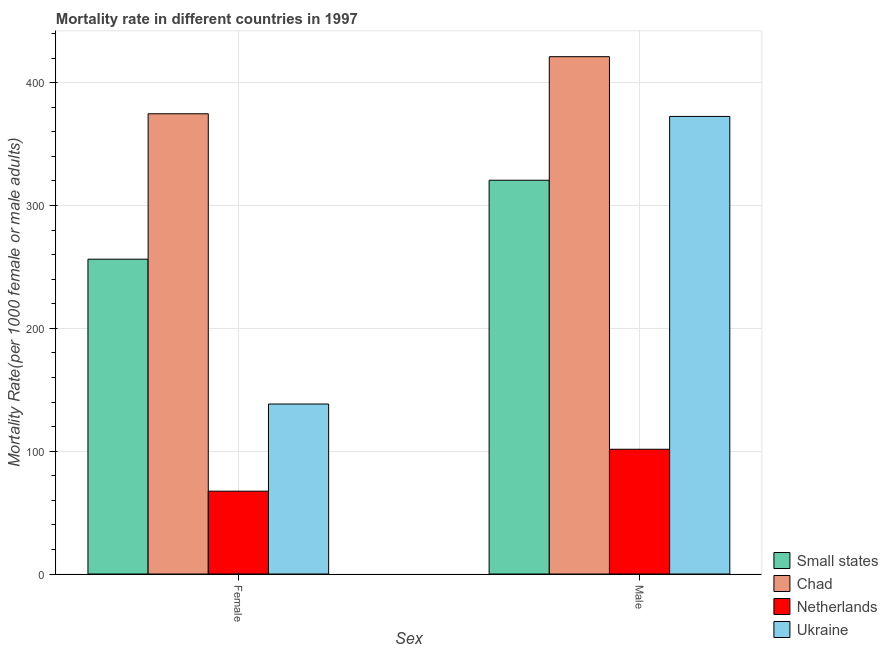Are the number of bars per tick equal to the number of legend labels?
Give a very brief answer. Yes. What is the female mortality rate in Netherlands?
Your answer should be very brief. 67.42. Across all countries, what is the maximum male mortality rate?
Your response must be concise. 421.15. Across all countries, what is the minimum male mortality rate?
Make the answer very short. 101.55. In which country was the female mortality rate maximum?
Your answer should be compact. Chad. What is the total male mortality rate in the graph?
Give a very brief answer. 1215.79. What is the difference between the female mortality rate in Chad and that in Ukraine?
Keep it short and to the point. 236.3. What is the difference between the male mortality rate in Small states and the female mortality rate in Chad?
Your answer should be very brief. -54.11. What is the average female mortality rate per country?
Ensure brevity in your answer.  209.19. What is the difference between the female mortality rate and male mortality rate in Ukraine?
Provide a succinct answer. -234.13. In how many countries, is the male mortality rate greater than 80 ?
Keep it short and to the point. 4. What is the ratio of the male mortality rate in Netherlands to that in Small states?
Provide a short and direct response. 0.32. In how many countries, is the female mortality rate greater than the average female mortality rate taken over all countries?
Provide a succinct answer. 2. What does the 1st bar from the left in Male represents?
Offer a very short reply. Small states. What does the 1st bar from the right in Female represents?
Keep it short and to the point. Ukraine. How many bars are there?
Give a very brief answer. 8. How many countries are there in the graph?
Provide a succinct answer. 4. What is the difference between two consecutive major ticks on the Y-axis?
Your response must be concise. 100. Does the graph contain any zero values?
Your answer should be compact. No. How many legend labels are there?
Ensure brevity in your answer.  4. What is the title of the graph?
Provide a succinct answer. Mortality rate in different countries in 1997. What is the label or title of the X-axis?
Your response must be concise. Sex. What is the label or title of the Y-axis?
Make the answer very short. Mortality Rate(per 1000 female or male adults). What is the Mortality Rate(per 1000 female or male adults) in Small states in Female?
Your response must be concise. 256.29. What is the Mortality Rate(per 1000 female or male adults) of Chad in Female?
Offer a terse response. 374.68. What is the Mortality Rate(per 1000 female or male adults) in Netherlands in Female?
Give a very brief answer. 67.42. What is the Mortality Rate(per 1000 female or male adults) of Ukraine in Female?
Your response must be concise. 138.38. What is the Mortality Rate(per 1000 female or male adults) of Small states in Male?
Offer a terse response. 320.57. What is the Mortality Rate(per 1000 female or male adults) of Chad in Male?
Make the answer very short. 421.15. What is the Mortality Rate(per 1000 female or male adults) of Netherlands in Male?
Your answer should be compact. 101.55. What is the Mortality Rate(per 1000 female or male adults) in Ukraine in Male?
Keep it short and to the point. 372.51. Across all Sex, what is the maximum Mortality Rate(per 1000 female or male adults) in Small states?
Your response must be concise. 320.57. Across all Sex, what is the maximum Mortality Rate(per 1000 female or male adults) in Chad?
Your answer should be compact. 421.15. Across all Sex, what is the maximum Mortality Rate(per 1000 female or male adults) in Netherlands?
Keep it short and to the point. 101.55. Across all Sex, what is the maximum Mortality Rate(per 1000 female or male adults) of Ukraine?
Make the answer very short. 372.51. Across all Sex, what is the minimum Mortality Rate(per 1000 female or male adults) in Small states?
Make the answer very short. 256.29. Across all Sex, what is the minimum Mortality Rate(per 1000 female or male adults) of Chad?
Make the answer very short. 374.68. Across all Sex, what is the minimum Mortality Rate(per 1000 female or male adults) in Netherlands?
Ensure brevity in your answer.  67.42. Across all Sex, what is the minimum Mortality Rate(per 1000 female or male adults) of Ukraine?
Provide a short and direct response. 138.38. What is the total Mortality Rate(per 1000 female or male adults) in Small states in the graph?
Provide a succinct answer. 576.86. What is the total Mortality Rate(per 1000 female or male adults) in Chad in the graph?
Offer a terse response. 795.83. What is the total Mortality Rate(per 1000 female or male adults) in Netherlands in the graph?
Offer a terse response. 168.98. What is the total Mortality Rate(per 1000 female or male adults) of Ukraine in the graph?
Give a very brief answer. 510.89. What is the difference between the Mortality Rate(per 1000 female or male adults) in Small states in Female and that in Male?
Keep it short and to the point. -64.28. What is the difference between the Mortality Rate(per 1000 female or male adults) of Chad in Female and that in Male?
Offer a very short reply. -46.47. What is the difference between the Mortality Rate(per 1000 female or male adults) of Netherlands in Female and that in Male?
Ensure brevity in your answer.  -34.13. What is the difference between the Mortality Rate(per 1000 female or male adults) of Ukraine in Female and that in Male?
Offer a very short reply. -234.13. What is the difference between the Mortality Rate(per 1000 female or male adults) in Small states in Female and the Mortality Rate(per 1000 female or male adults) in Chad in Male?
Offer a terse response. -164.86. What is the difference between the Mortality Rate(per 1000 female or male adults) in Small states in Female and the Mortality Rate(per 1000 female or male adults) in Netherlands in Male?
Your response must be concise. 154.73. What is the difference between the Mortality Rate(per 1000 female or male adults) of Small states in Female and the Mortality Rate(per 1000 female or male adults) of Ukraine in Male?
Provide a short and direct response. -116.22. What is the difference between the Mortality Rate(per 1000 female or male adults) in Chad in Female and the Mortality Rate(per 1000 female or male adults) in Netherlands in Male?
Provide a succinct answer. 273.13. What is the difference between the Mortality Rate(per 1000 female or male adults) in Chad in Female and the Mortality Rate(per 1000 female or male adults) in Ukraine in Male?
Ensure brevity in your answer.  2.17. What is the difference between the Mortality Rate(per 1000 female or male adults) in Netherlands in Female and the Mortality Rate(per 1000 female or male adults) in Ukraine in Male?
Your response must be concise. -305.09. What is the average Mortality Rate(per 1000 female or male adults) of Small states per Sex?
Give a very brief answer. 288.43. What is the average Mortality Rate(per 1000 female or male adults) of Chad per Sex?
Provide a short and direct response. 397.92. What is the average Mortality Rate(per 1000 female or male adults) in Netherlands per Sex?
Your response must be concise. 84.49. What is the average Mortality Rate(per 1000 female or male adults) of Ukraine per Sex?
Give a very brief answer. 255.45. What is the difference between the Mortality Rate(per 1000 female or male adults) in Small states and Mortality Rate(per 1000 female or male adults) in Chad in Female?
Provide a succinct answer. -118.39. What is the difference between the Mortality Rate(per 1000 female or male adults) in Small states and Mortality Rate(per 1000 female or male adults) in Netherlands in Female?
Give a very brief answer. 188.87. What is the difference between the Mortality Rate(per 1000 female or male adults) of Small states and Mortality Rate(per 1000 female or male adults) of Ukraine in Female?
Provide a succinct answer. 117.91. What is the difference between the Mortality Rate(per 1000 female or male adults) of Chad and Mortality Rate(per 1000 female or male adults) of Netherlands in Female?
Your response must be concise. 307.26. What is the difference between the Mortality Rate(per 1000 female or male adults) in Chad and Mortality Rate(per 1000 female or male adults) in Ukraine in Female?
Your answer should be compact. 236.3. What is the difference between the Mortality Rate(per 1000 female or male adults) in Netherlands and Mortality Rate(per 1000 female or male adults) in Ukraine in Female?
Give a very brief answer. -70.96. What is the difference between the Mortality Rate(per 1000 female or male adults) in Small states and Mortality Rate(per 1000 female or male adults) in Chad in Male?
Offer a terse response. -100.58. What is the difference between the Mortality Rate(per 1000 female or male adults) of Small states and Mortality Rate(per 1000 female or male adults) of Netherlands in Male?
Make the answer very short. 219.01. What is the difference between the Mortality Rate(per 1000 female or male adults) in Small states and Mortality Rate(per 1000 female or male adults) in Ukraine in Male?
Provide a succinct answer. -51.94. What is the difference between the Mortality Rate(per 1000 female or male adults) of Chad and Mortality Rate(per 1000 female or male adults) of Netherlands in Male?
Provide a short and direct response. 319.6. What is the difference between the Mortality Rate(per 1000 female or male adults) in Chad and Mortality Rate(per 1000 female or male adults) in Ukraine in Male?
Offer a very short reply. 48.64. What is the difference between the Mortality Rate(per 1000 female or male adults) in Netherlands and Mortality Rate(per 1000 female or male adults) in Ukraine in Male?
Ensure brevity in your answer.  -270.96. What is the ratio of the Mortality Rate(per 1000 female or male adults) in Small states in Female to that in Male?
Your answer should be very brief. 0.8. What is the ratio of the Mortality Rate(per 1000 female or male adults) of Chad in Female to that in Male?
Offer a very short reply. 0.89. What is the ratio of the Mortality Rate(per 1000 female or male adults) in Netherlands in Female to that in Male?
Your answer should be compact. 0.66. What is the ratio of the Mortality Rate(per 1000 female or male adults) in Ukraine in Female to that in Male?
Your answer should be very brief. 0.37. What is the difference between the highest and the second highest Mortality Rate(per 1000 female or male adults) of Small states?
Provide a short and direct response. 64.28. What is the difference between the highest and the second highest Mortality Rate(per 1000 female or male adults) in Chad?
Make the answer very short. 46.47. What is the difference between the highest and the second highest Mortality Rate(per 1000 female or male adults) in Netherlands?
Provide a short and direct response. 34.13. What is the difference between the highest and the second highest Mortality Rate(per 1000 female or male adults) in Ukraine?
Keep it short and to the point. 234.13. What is the difference between the highest and the lowest Mortality Rate(per 1000 female or male adults) of Small states?
Make the answer very short. 64.28. What is the difference between the highest and the lowest Mortality Rate(per 1000 female or male adults) in Chad?
Offer a very short reply. 46.47. What is the difference between the highest and the lowest Mortality Rate(per 1000 female or male adults) of Netherlands?
Your answer should be compact. 34.13. What is the difference between the highest and the lowest Mortality Rate(per 1000 female or male adults) of Ukraine?
Make the answer very short. 234.13. 